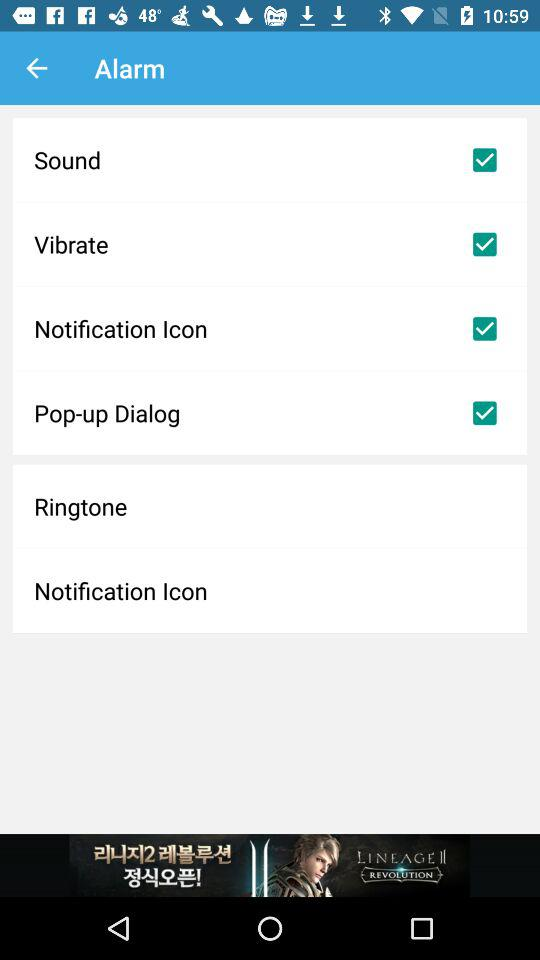Which checkbox is checked? The checked checkboxes are "Sound", "Vibrate", "Notification Icon" and "Pop-up Dialog". 